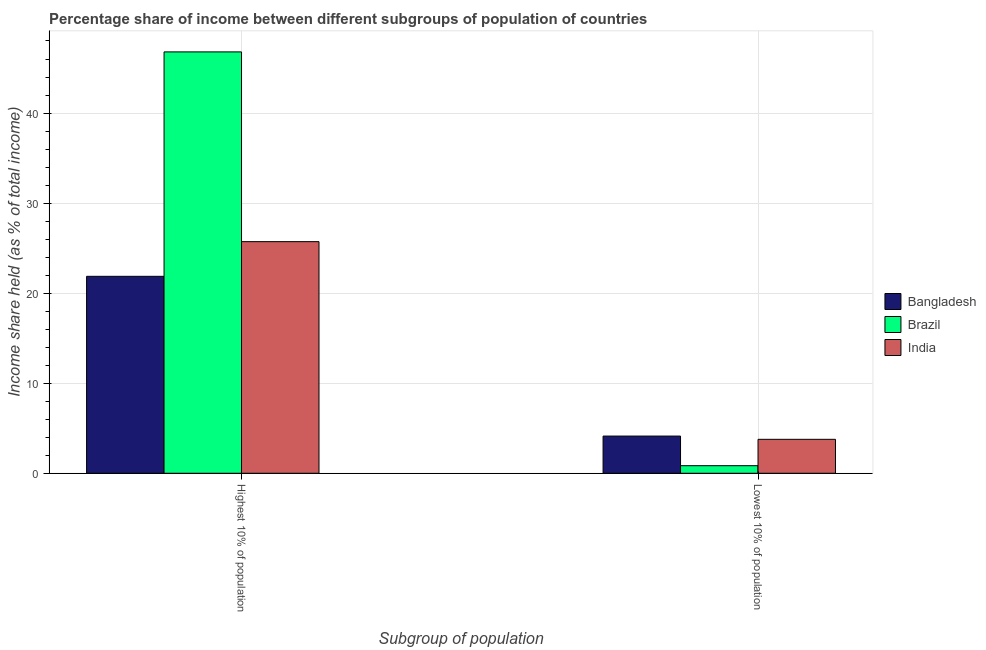Are the number of bars on each tick of the X-axis equal?
Your response must be concise. Yes. How many bars are there on the 2nd tick from the right?
Your answer should be compact. 3. What is the label of the 1st group of bars from the left?
Make the answer very short. Highest 10% of population. What is the income share held by lowest 10% of the population in India?
Provide a short and direct response. 3.77. Across all countries, what is the maximum income share held by highest 10% of the population?
Provide a succinct answer. 46.79. Across all countries, what is the minimum income share held by lowest 10% of the population?
Make the answer very short. 0.84. In which country was the income share held by lowest 10% of the population minimum?
Your answer should be compact. Brazil. What is the total income share held by lowest 10% of the population in the graph?
Offer a very short reply. 8.74. What is the difference between the income share held by highest 10% of the population in Bangladesh and that in Brazil?
Give a very brief answer. -24.92. What is the difference between the income share held by highest 10% of the population in Brazil and the income share held by lowest 10% of the population in India?
Give a very brief answer. 43.02. What is the average income share held by highest 10% of the population per country?
Ensure brevity in your answer.  31.46. What is the difference between the income share held by lowest 10% of the population and income share held by highest 10% of the population in Bangladesh?
Your response must be concise. -17.74. What is the ratio of the income share held by lowest 10% of the population in Bangladesh to that in Brazil?
Offer a terse response. 4.92. In how many countries, is the income share held by highest 10% of the population greater than the average income share held by highest 10% of the population taken over all countries?
Keep it short and to the point. 1. What does the 2nd bar from the left in Highest 10% of population represents?
Provide a short and direct response. Brazil. Are all the bars in the graph horizontal?
Provide a succinct answer. No. What is the difference between two consecutive major ticks on the Y-axis?
Your answer should be compact. 10. Are the values on the major ticks of Y-axis written in scientific E-notation?
Your answer should be very brief. No. Does the graph contain any zero values?
Keep it short and to the point. No. Does the graph contain grids?
Your answer should be compact. Yes. Where does the legend appear in the graph?
Make the answer very short. Center right. What is the title of the graph?
Your response must be concise. Percentage share of income between different subgroups of population of countries. What is the label or title of the X-axis?
Your answer should be compact. Subgroup of population. What is the label or title of the Y-axis?
Your answer should be compact. Income share held (as % of total income). What is the Income share held (as % of total income) in Bangladesh in Highest 10% of population?
Offer a very short reply. 21.87. What is the Income share held (as % of total income) of Brazil in Highest 10% of population?
Your answer should be very brief. 46.79. What is the Income share held (as % of total income) of India in Highest 10% of population?
Give a very brief answer. 25.72. What is the Income share held (as % of total income) of Bangladesh in Lowest 10% of population?
Your answer should be compact. 4.13. What is the Income share held (as % of total income) of Brazil in Lowest 10% of population?
Your answer should be very brief. 0.84. What is the Income share held (as % of total income) in India in Lowest 10% of population?
Your response must be concise. 3.77. Across all Subgroup of population, what is the maximum Income share held (as % of total income) in Bangladesh?
Offer a very short reply. 21.87. Across all Subgroup of population, what is the maximum Income share held (as % of total income) of Brazil?
Your response must be concise. 46.79. Across all Subgroup of population, what is the maximum Income share held (as % of total income) of India?
Ensure brevity in your answer.  25.72. Across all Subgroup of population, what is the minimum Income share held (as % of total income) in Bangladesh?
Offer a very short reply. 4.13. Across all Subgroup of population, what is the minimum Income share held (as % of total income) of Brazil?
Your response must be concise. 0.84. Across all Subgroup of population, what is the minimum Income share held (as % of total income) of India?
Offer a very short reply. 3.77. What is the total Income share held (as % of total income) of Bangladesh in the graph?
Make the answer very short. 26. What is the total Income share held (as % of total income) of Brazil in the graph?
Your response must be concise. 47.63. What is the total Income share held (as % of total income) of India in the graph?
Make the answer very short. 29.49. What is the difference between the Income share held (as % of total income) in Bangladesh in Highest 10% of population and that in Lowest 10% of population?
Give a very brief answer. 17.74. What is the difference between the Income share held (as % of total income) of Brazil in Highest 10% of population and that in Lowest 10% of population?
Provide a succinct answer. 45.95. What is the difference between the Income share held (as % of total income) in India in Highest 10% of population and that in Lowest 10% of population?
Your answer should be very brief. 21.95. What is the difference between the Income share held (as % of total income) in Bangladesh in Highest 10% of population and the Income share held (as % of total income) in Brazil in Lowest 10% of population?
Your answer should be compact. 21.03. What is the difference between the Income share held (as % of total income) in Bangladesh in Highest 10% of population and the Income share held (as % of total income) in India in Lowest 10% of population?
Your answer should be compact. 18.1. What is the difference between the Income share held (as % of total income) of Brazil in Highest 10% of population and the Income share held (as % of total income) of India in Lowest 10% of population?
Your answer should be very brief. 43.02. What is the average Income share held (as % of total income) of Bangladesh per Subgroup of population?
Your answer should be compact. 13. What is the average Income share held (as % of total income) in Brazil per Subgroup of population?
Your answer should be compact. 23.82. What is the average Income share held (as % of total income) of India per Subgroup of population?
Your answer should be compact. 14.74. What is the difference between the Income share held (as % of total income) of Bangladesh and Income share held (as % of total income) of Brazil in Highest 10% of population?
Offer a terse response. -24.92. What is the difference between the Income share held (as % of total income) of Bangladesh and Income share held (as % of total income) of India in Highest 10% of population?
Make the answer very short. -3.85. What is the difference between the Income share held (as % of total income) of Brazil and Income share held (as % of total income) of India in Highest 10% of population?
Keep it short and to the point. 21.07. What is the difference between the Income share held (as % of total income) of Bangladesh and Income share held (as % of total income) of Brazil in Lowest 10% of population?
Provide a succinct answer. 3.29. What is the difference between the Income share held (as % of total income) in Bangladesh and Income share held (as % of total income) in India in Lowest 10% of population?
Keep it short and to the point. 0.36. What is the difference between the Income share held (as % of total income) of Brazil and Income share held (as % of total income) of India in Lowest 10% of population?
Offer a very short reply. -2.93. What is the ratio of the Income share held (as % of total income) in Bangladesh in Highest 10% of population to that in Lowest 10% of population?
Ensure brevity in your answer.  5.3. What is the ratio of the Income share held (as % of total income) of Brazil in Highest 10% of population to that in Lowest 10% of population?
Provide a short and direct response. 55.7. What is the ratio of the Income share held (as % of total income) in India in Highest 10% of population to that in Lowest 10% of population?
Give a very brief answer. 6.82. What is the difference between the highest and the second highest Income share held (as % of total income) of Bangladesh?
Give a very brief answer. 17.74. What is the difference between the highest and the second highest Income share held (as % of total income) in Brazil?
Your answer should be compact. 45.95. What is the difference between the highest and the second highest Income share held (as % of total income) in India?
Keep it short and to the point. 21.95. What is the difference between the highest and the lowest Income share held (as % of total income) in Bangladesh?
Ensure brevity in your answer.  17.74. What is the difference between the highest and the lowest Income share held (as % of total income) of Brazil?
Your answer should be very brief. 45.95. What is the difference between the highest and the lowest Income share held (as % of total income) in India?
Make the answer very short. 21.95. 